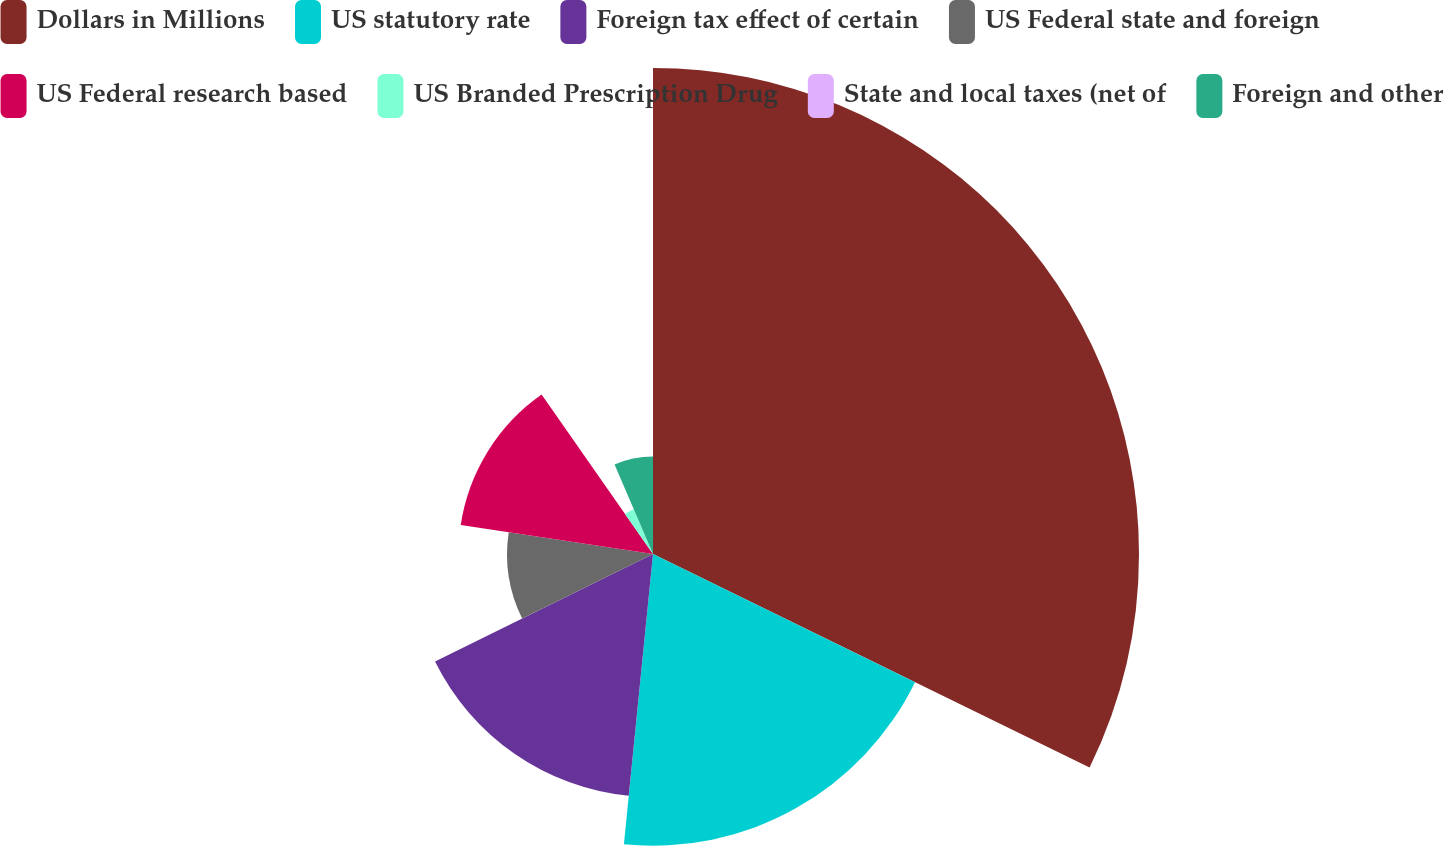<chart> <loc_0><loc_0><loc_500><loc_500><pie_chart><fcel>Dollars in Millions<fcel>US statutory rate<fcel>Foreign tax effect of certain<fcel>US Federal state and foreign<fcel>US Federal research based<fcel>US Branded Prescription Drug<fcel>State and local taxes (net of<fcel>Foreign and other<nl><fcel>32.24%<fcel>19.35%<fcel>16.12%<fcel>9.68%<fcel>12.9%<fcel>3.24%<fcel>0.01%<fcel>6.46%<nl></chart> 